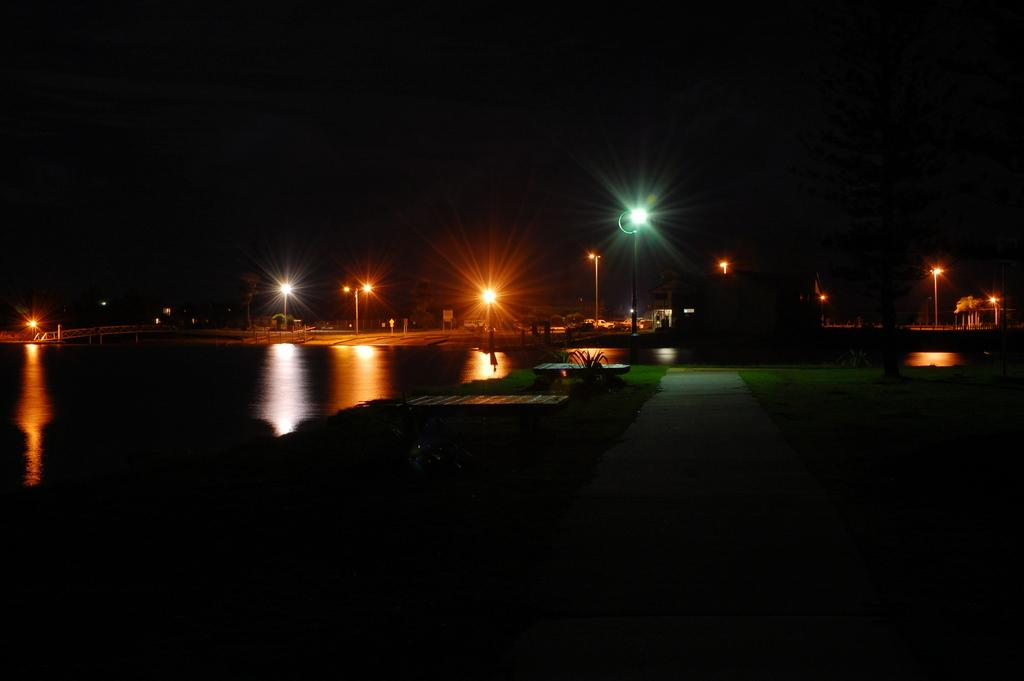What is the color of the background in the image? The background of the image is dark. What natural element can be seen in the image? There is water visible in the image. What type of structures are present in the image? There are light poles in the image. What type of vegetation is present in the image? There are plants and grass in the image. What is the unspecified object in the image? There are unspecified objects in the image, but we cannot describe them without more information. Where is the bridge located in the image? The bridge is on the left side of the image. What type of leather is used to cover the books in the library in the image? There is no library or leather present in the image. What type of yoke is being used by the animals in the image? There are no animals or yokes present in the image. 